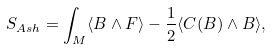Convert formula to latex. <formula><loc_0><loc_0><loc_500><loc_500>S _ { A s h } = \int _ { M } \langle B \wedge F \rangle - \frac { 1 } { 2 } \langle C ( B ) \wedge B \rangle ,</formula> 